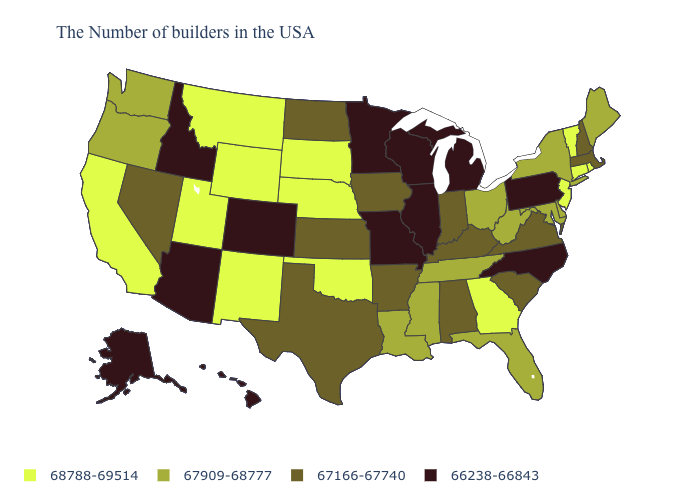What is the value of Oregon?
Give a very brief answer. 67909-68777. Does South Carolina have a lower value than Arkansas?
Answer briefly. No. Name the states that have a value in the range 66238-66843?
Quick response, please. Pennsylvania, North Carolina, Michigan, Wisconsin, Illinois, Missouri, Minnesota, Colorado, Arizona, Idaho, Alaska, Hawaii. Does the first symbol in the legend represent the smallest category?
Quick response, please. No. Name the states that have a value in the range 67166-67740?
Be succinct. Massachusetts, New Hampshire, Virginia, South Carolina, Kentucky, Indiana, Alabama, Arkansas, Iowa, Kansas, Texas, North Dakota, Nevada. What is the value of North Carolina?
Keep it brief. 66238-66843. Name the states that have a value in the range 67909-68777?
Write a very short answer. Maine, New York, Delaware, Maryland, West Virginia, Ohio, Florida, Tennessee, Mississippi, Louisiana, Washington, Oregon. Does the map have missing data?
Quick response, please. No. Is the legend a continuous bar?
Be succinct. No. Among the states that border Montana , which have the lowest value?
Be succinct. Idaho. What is the value of Indiana?
Write a very short answer. 67166-67740. Name the states that have a value in the range 68788-69514?
Give a very brief answer. Rhode Island, Vermont, Connecticut, New Jersey, Georgia, Nebraska, Oklahoma, South Dakota, Wyoming, New Mexico, Utah, Montana, California. Does Georgia have the highest value in the South?
Keep it brief. Yes. Among the states that border Kentucky , does Illinois have the lowest value?
Give a very brief answer. Yes. What is the lowest value in states that border Minnesota?
Be succinct. 66238-66843. 